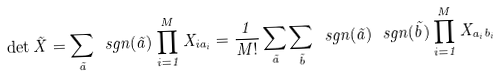<formula> <loc_0><loc_0><loc_500><loc_500>\det \vec { X } = \sum _ { \vec { a } } \ s g n ( \vec { a } ) \prod _ { i = 1 } ^ { M } X _ { i a _ { i } } = \frac { 1 } { M ! } \sum _ { \vec { a } } \sum _ { \vec { b } } \ s g n ( \vec { a } ) \, \ s g n ( \vec { b } ) \prod _ { i = 1 } ^ { M } X _ { a _ { i } b _ { i } }</formula> 